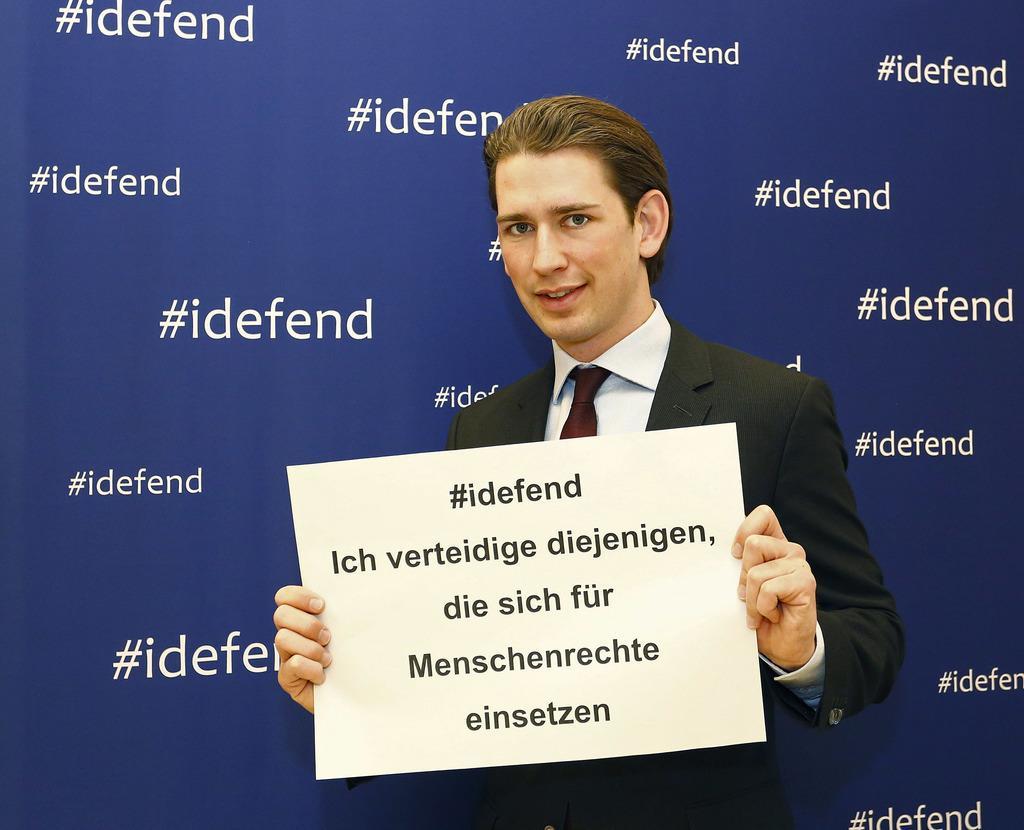In one or two sentences, can you explain what this image depicts? This picture consists of person holding a notice paper , on the paper there is a text and in the background I can see a board , on the board i can see a blue color and text visible on it. 